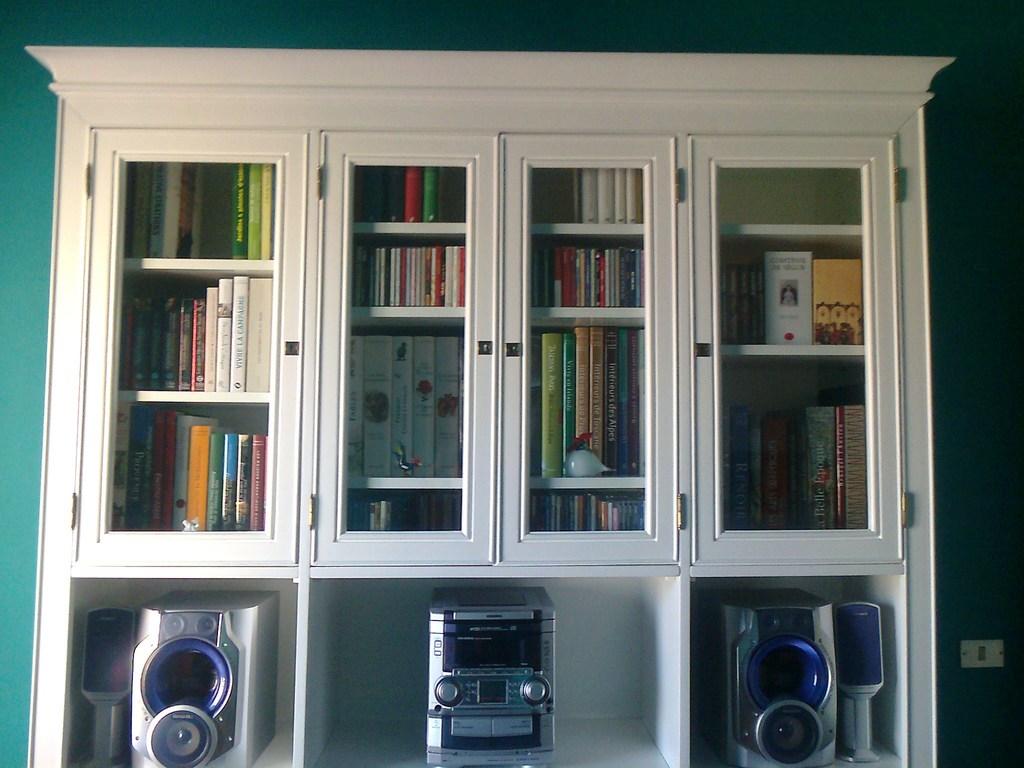What is the first leter of the blue book on the left?
Your answer should be compact. P. 